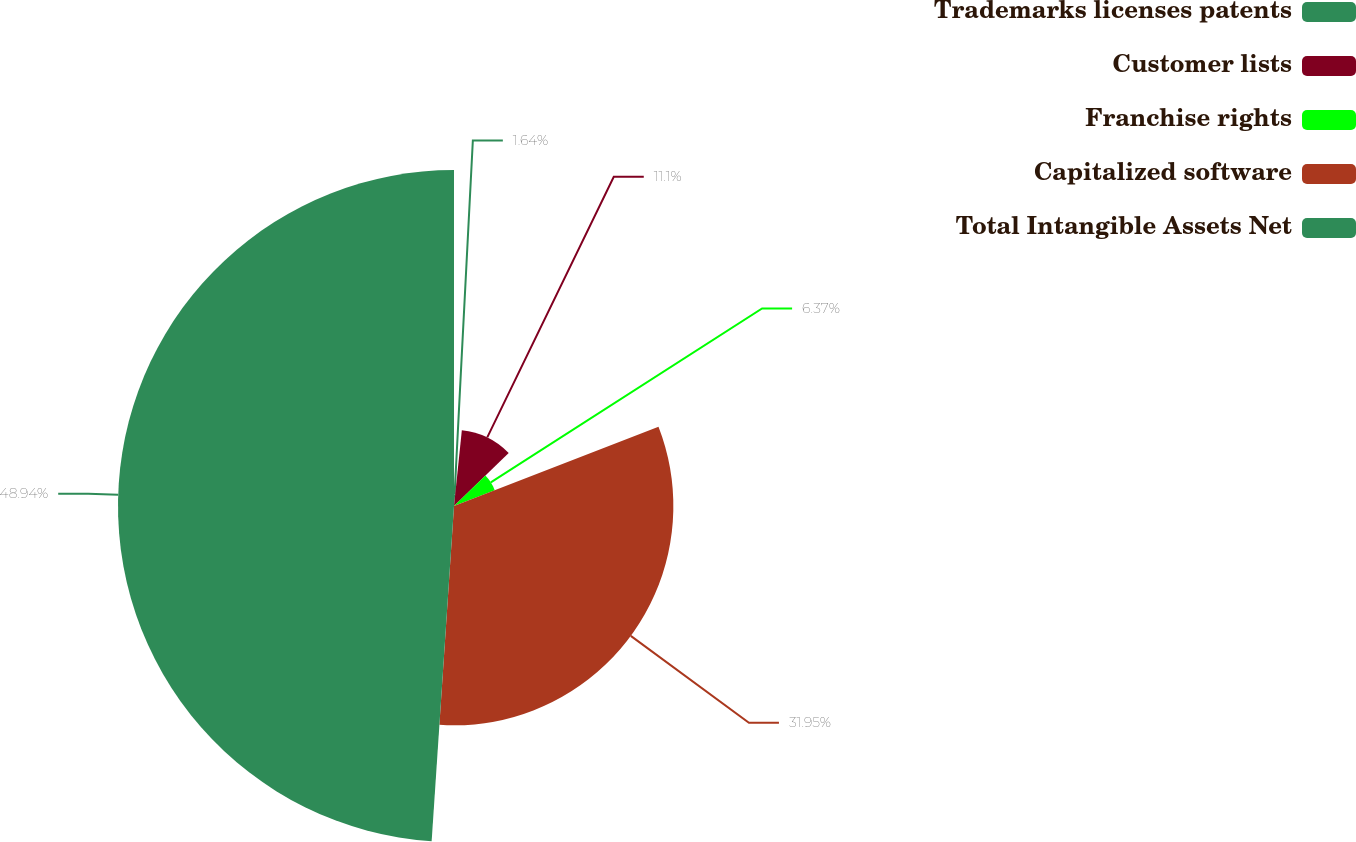<chart> <loc_0><loc_0><loc_500><loc_500><pie_chart><fcel>Trademarks licenses patents<fcel>Customer lists<fcel>Franchise rights<fcel>Capitalized software<fcel>Total Intangible Assets Net<nl><fcel>1.64%<fcel>11.1%<fcel>6.37%<fcel>31.95%<fcel>48.94%<nl></chart> 